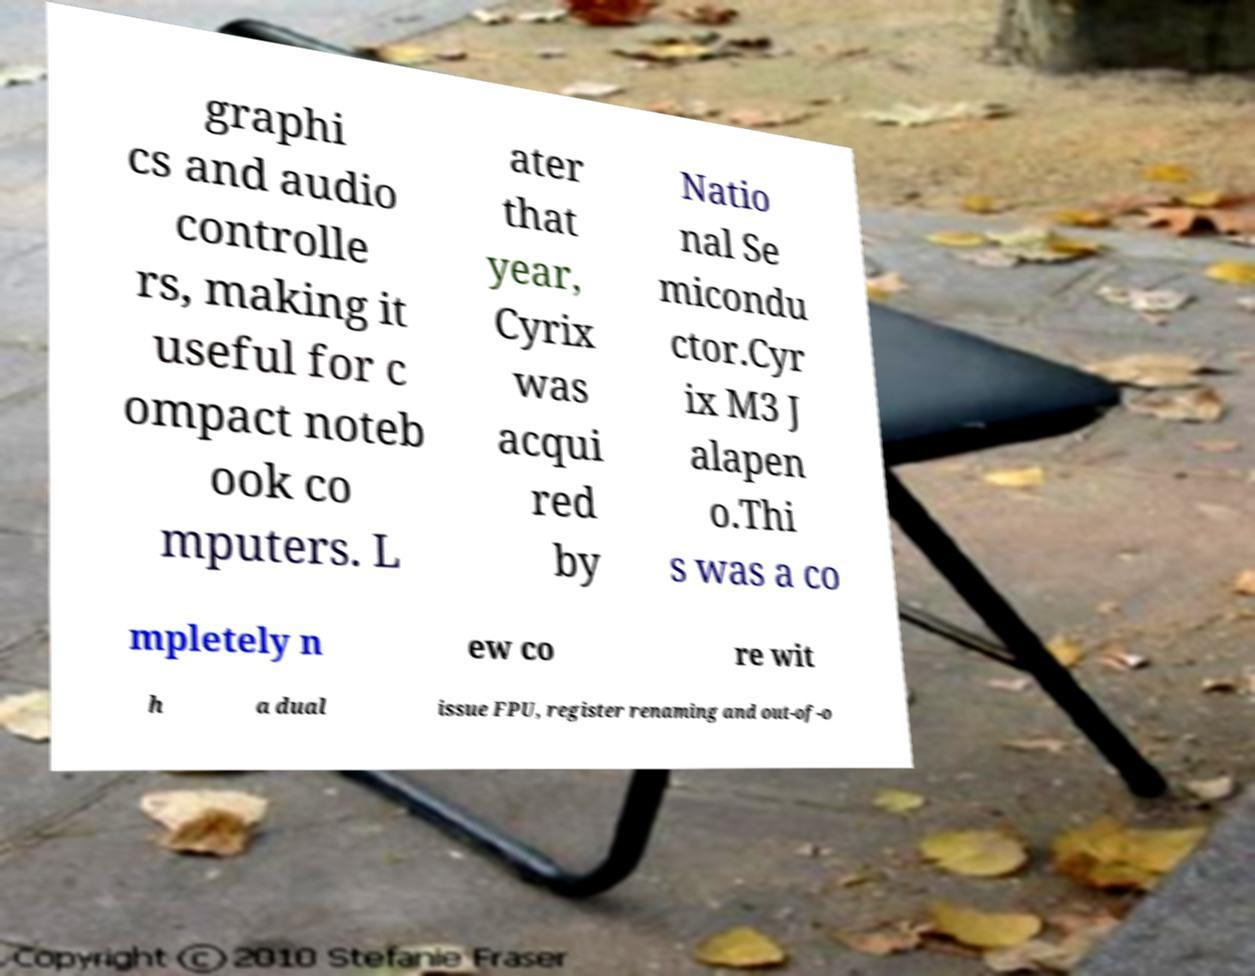What messages or text are displayed in this image? I need them in a readable, typed format. graphi cs and audio controlle rs, making it useful for c ompact noteb ook co mputers. L ater that year, Cyrix was acqui red by Natio nal Se micondu ctor.Cyr ix M3 J alapen o.Thi s was a co mpletely n ew co re wit h a dual issue FPU, register renaming and out-of-o 